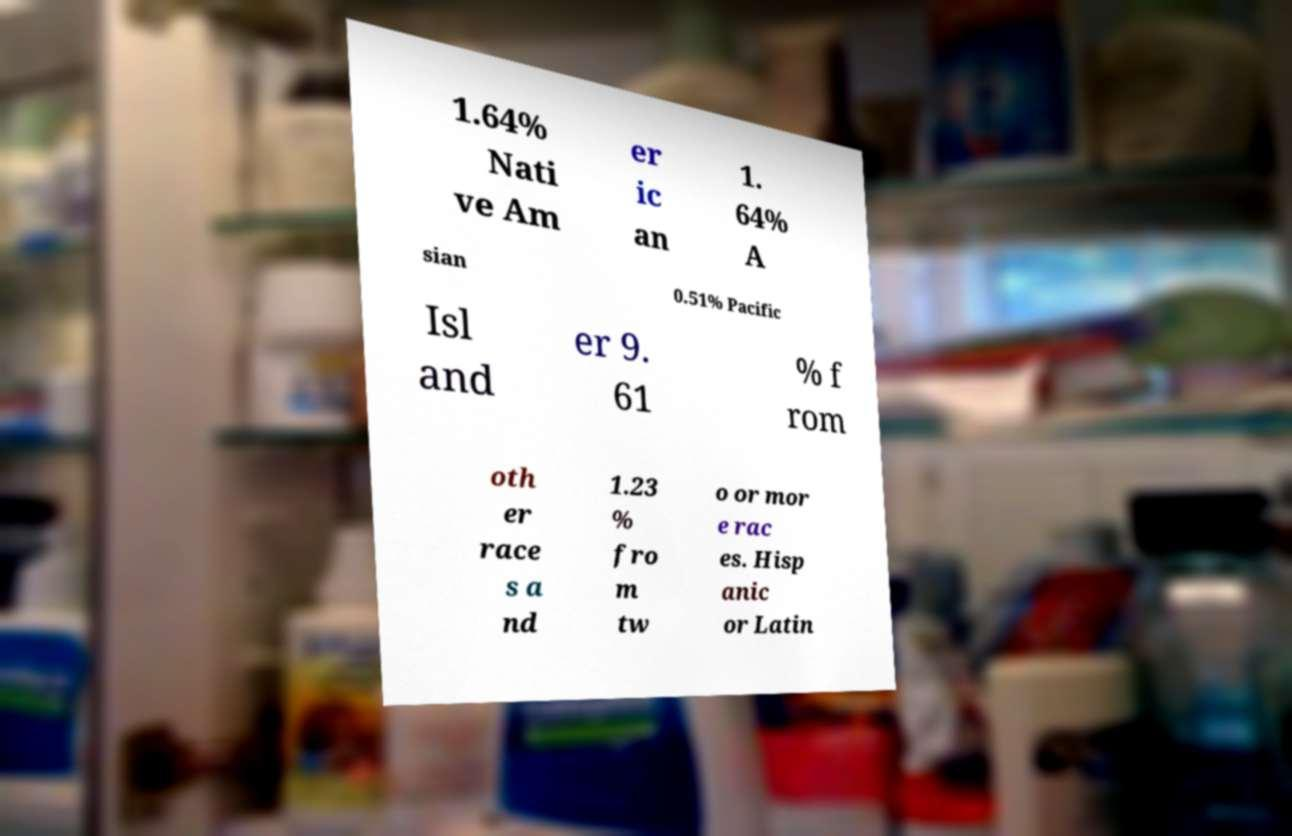Could you assist in decoding the text presented in this image and type it out clearly? 1.64% Nati ve Am er ic an 1. 64% A sian 0.51% Pacific Isl and er 9. 61 % f rom oth er race s a nd 1.23 % fro m tw o or mor e rac es. Hisp anic or Latin 